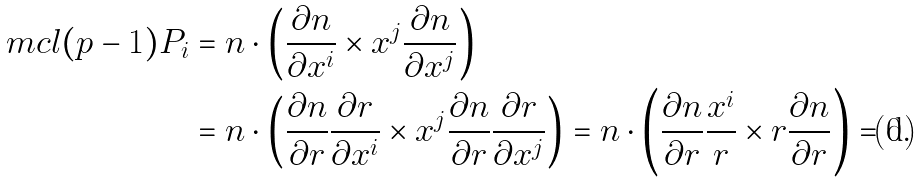<formula> <loc_0><loc_0><loc_500><loc_500>\ m c l ( p - 1 ) P _ { i } & = n \cdot \left ( \frac { \partial n } { \partial x ^ { i } } \times x ^ { j } \frac { \partial n } { \partial x ^ { j } } \right ) \\ & = n \cdot \left ( \frac { \partial n } { \partial r } \frac { \partial r } { \partial x ^ { i } } \times x ^ { j } \frac { \partial n } { \partial r } \frac { \partial r } { \partial x ^ { j } } \right ) = n \cdot \left ( \frac { \partial n } { \partial r } \frac { x ^ { i } } { r } \times r \frac { \partial n } { \partial r } \right ) = 0 .</formula> 